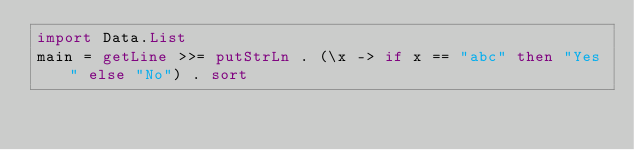<code> <loc_0><loc_0><loc_500><loc_500><_Haskell_>import Data.List
main = getLine >>= putStrLn . (\x -> if x == "abc" then "Yes" else "No") . sort</code> 